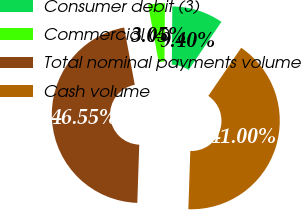Convert chart to OTSL. <chart><loc_0><loc_0><loc_500><loc_500><pie_chart><fcel>Consumer debit (3)<fcel>Commercial (4)<fcel>Total nominal payments volume<fcel>Cash volume<nl><fcel>9.4%<fcel>3.05%<fcel>46.55%<fcel>41.0%<nl></chart> 